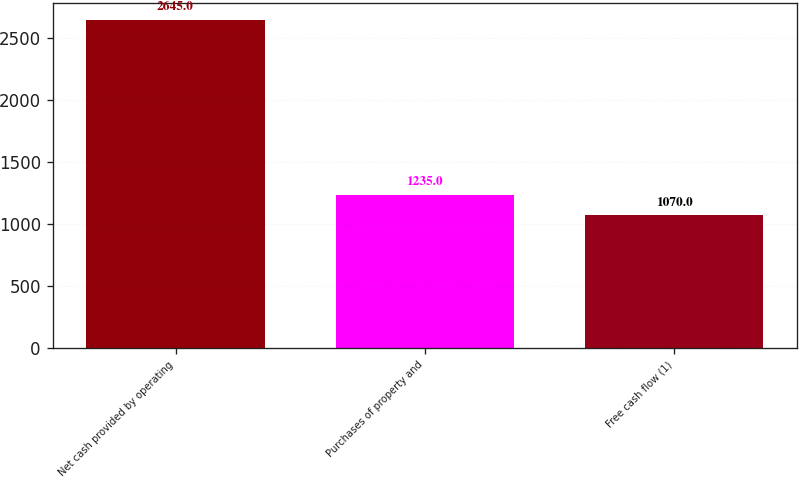<chart> <loc_0><loc_0><loc_500><loc_500><bar_chart><fcel>Net cash provided by operating<fcel>Purchases of property and<fcel>Free cash flow (1)<nl><fcel>2645<fcel>1235<fcel>1070<nl></chart> 